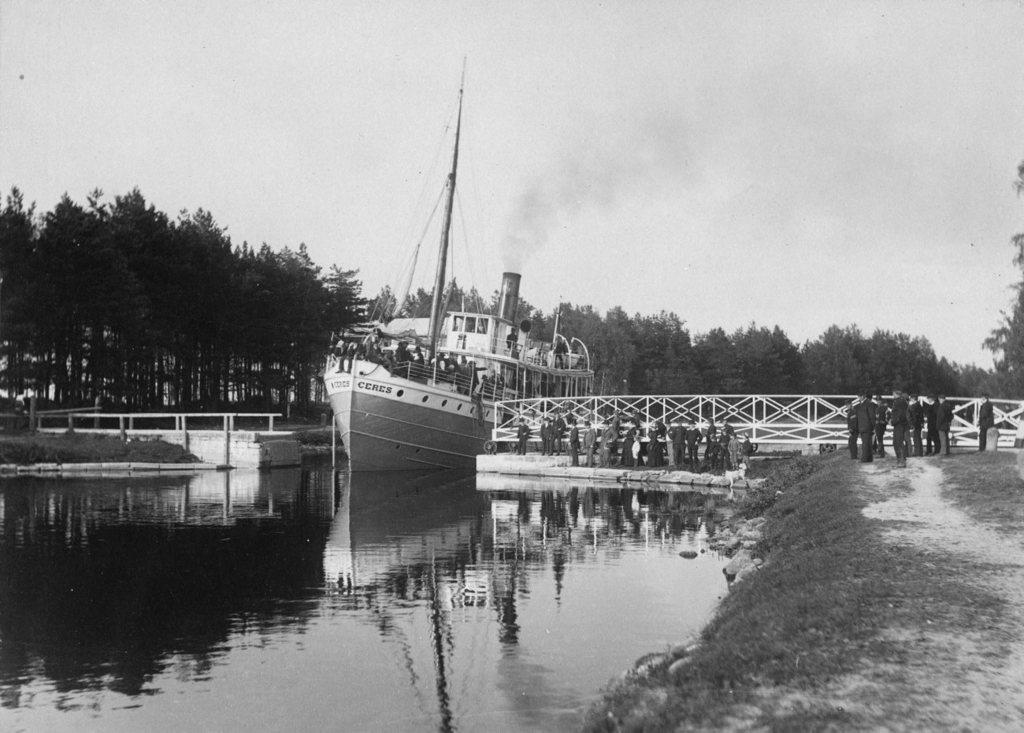How many persons are in the image? There are persons in the image. What is located on the water in the image? There is a ship on the water in the image. What type of vegetation is visible in the image? There is grass visible in the image. What type of structure can be seen in the image? There is a bridge in the image. What can be seen in the background of the image? There are trees and the sky visible in the background of the image. How many wings does the toad have in the image? There is no toad present in the image, and therefore no wings to count. What type of trees are depicted in the image? The provided facts do not specify the type of trees; they only mention that trees are present in the background. 